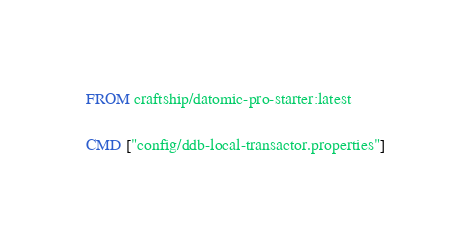<code> <loc_0><loc_0><loc_500><loc_500><_Dockerfile_>FROM craftship/datomic-pro-starter:latest

CMD ["config/ddb-local-transactor.properties"]
</code> 